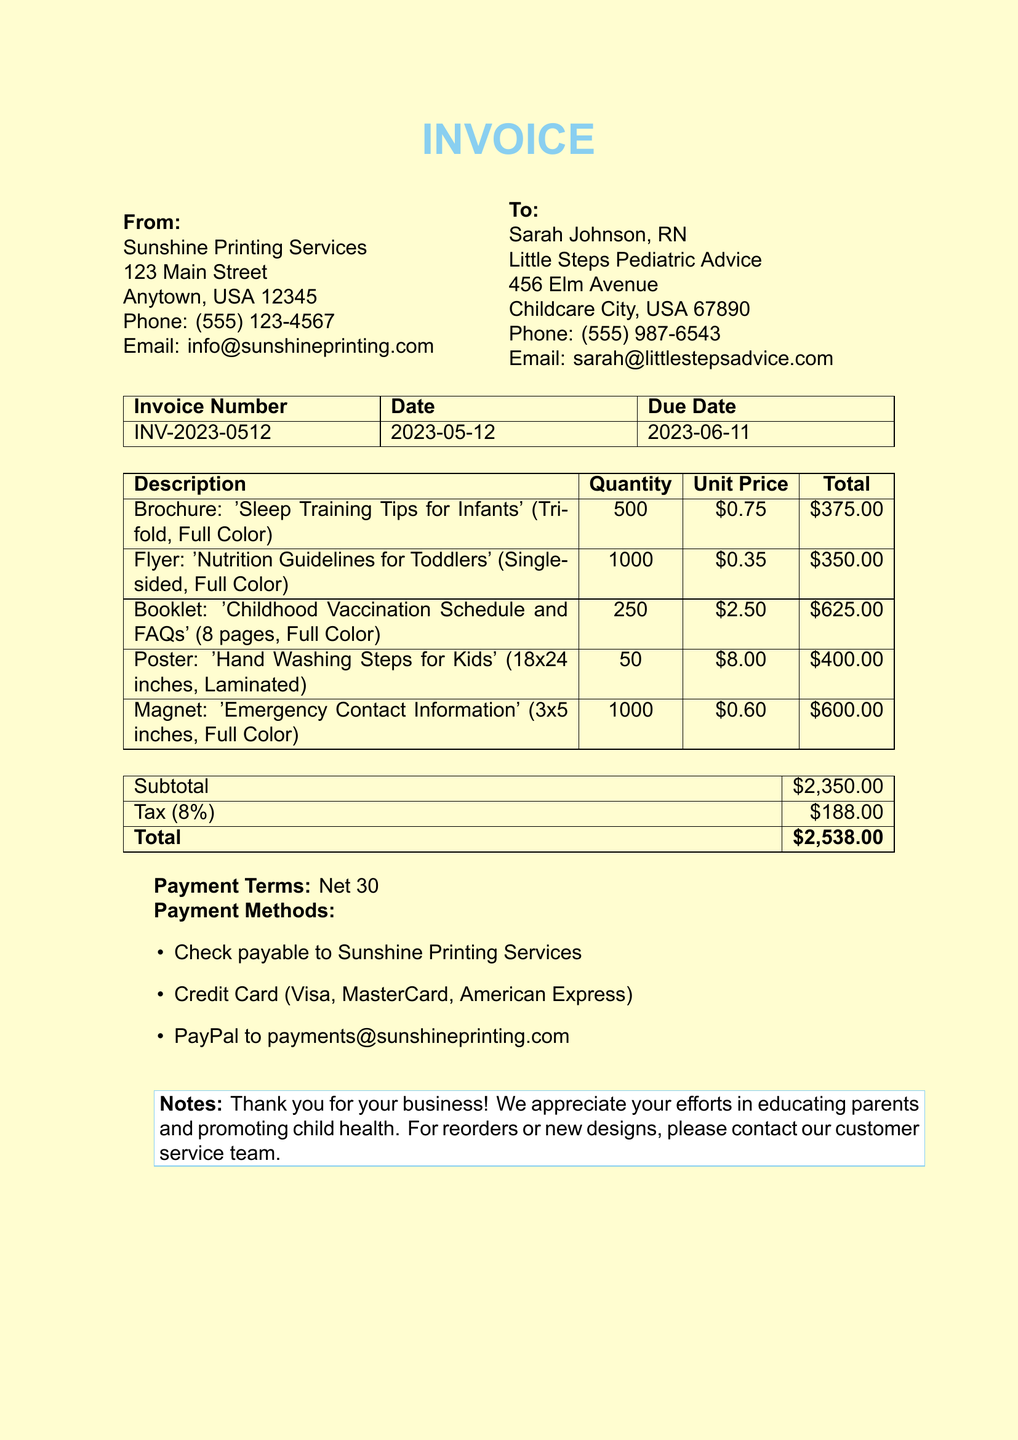What is the invoice number? The invoice number is listed at the top of the document for reference.
Answer: INV-2023-0512 What is the due date of the invoice? The due date is specified in the document for payment purposes.
Answer: 2023-06-11 Who is the recipient of the invoice? The recipient's name and business are provided in the "To" section.
Answer: Sarah Johnson, RN What is the total amount due? The total amount due is calculated and presented at the bottom of the invoice.
Answer: $2,538.00 How many flyers were ordered? The quantity of each item is detailed in the invoice, specifically the flyers.
Answer: 1000 What is the tax rate applied to the invoice? The tax rate is mentioned in the calculation section of the invoice.
Answer: 8% What is the payment term specified in the invoice? Payment terms are outlined in the invoice under payment terms.
Answer: Net 30 What method can be used to pay via PayPal? Payment methods are listed along with specific details on how to pay.
Answer: payments@sunshineprinting.com How many brochures were printed? The quantity of brochures ordered is clearly stated in the invoice.
Answer: 500 